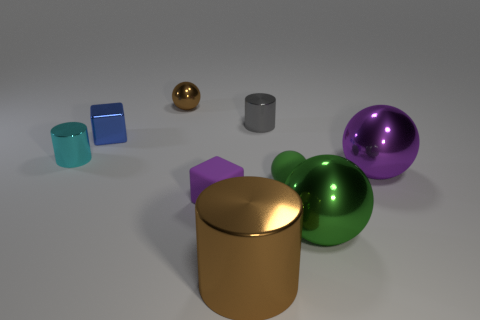Subtract all small cylinders. How many cylinders are left? 1 Subtract all spheres. How many objects are left? 5 Subtract 2 blocks. How many blocks are left? 0 Add 1 small purple cubes. How many objects exist? 10 Subtract all brown spheres. How many spheres are left? 3 Subtract all green spheres. How many gray cylinders are left? 1 Subtract all large gray metallic cubes. Subtract all tiny blue blocks. How many objects are left? 8 Add 2 green rubber things. How many green rubber things are left? 3 Add 4 yellow metal cylinders. How many yellow metal cylinders exist? 4 Subtract 0 yellow cubes. How many objects are left? 9 